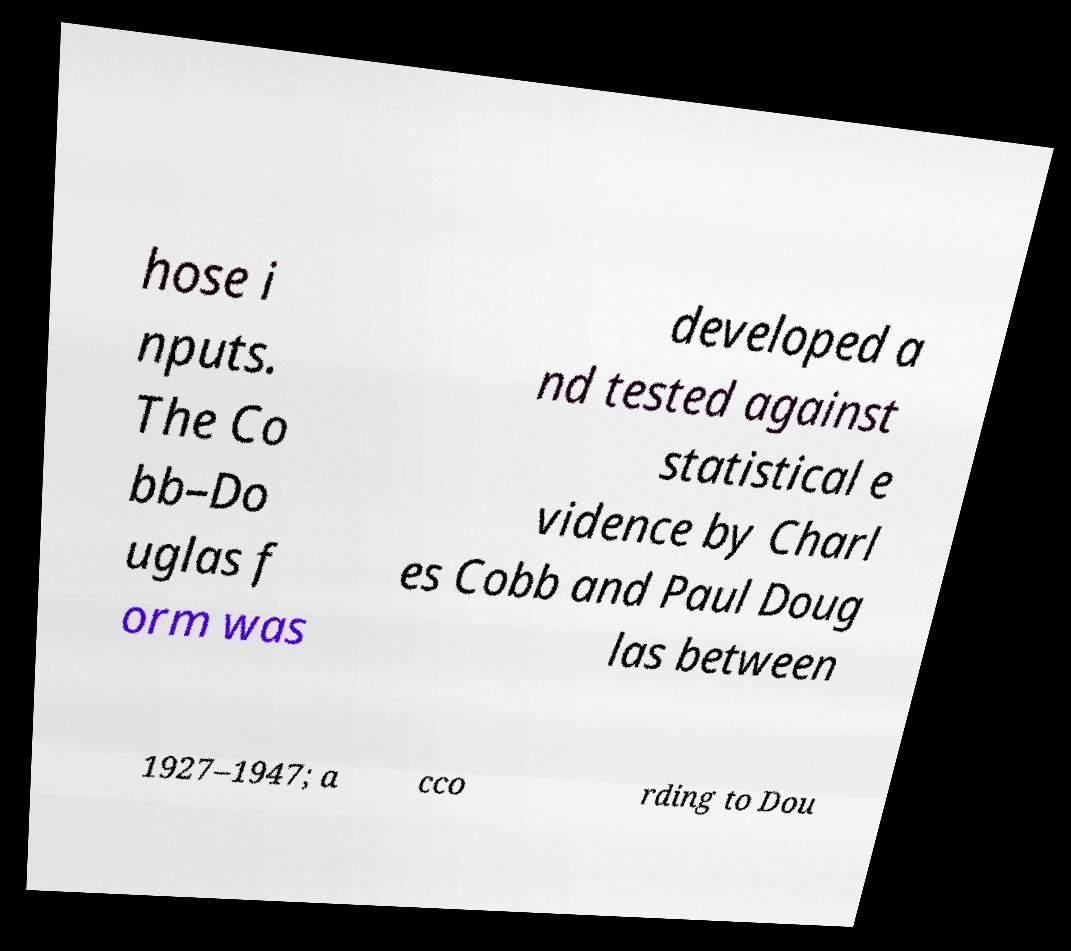Could you assist in decoding the text presented in this image and type it out clearly? hose i nputs. The Co bb–Do uglas f orm was developed a nd tested against statistical e vidence by Charl es Cobb and Paul Doug las between 1927–1947; a cco rding to Dou 